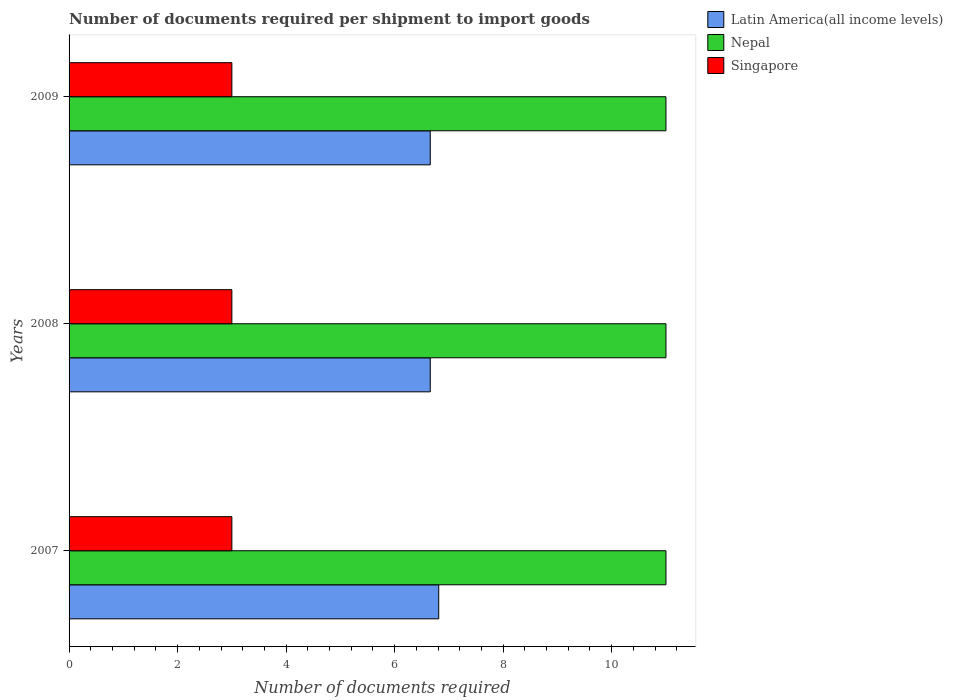How many different coloured bars are there?
Your response must be concise. 3. How many groups of bars are there?
Make the answer very short. 3. How many bars are there on the 1st tick from the top?
Keep it short and to the point. 3. How many bars are there on the 3rd tick from the bottom?
Offer a very short reply. 3. What is the label of the 2nd group of bars from the top?
Provide a short and direct response. 2008. In how many cases, is the number of bars for a given year not equal to the number of legend labels?
Offer a terse response. 0. What is the number of documents required per shipment to import goods in Nepal in 2009?
Provide a succinct answer. 11. Across all years, what is the maximum number of documents required per shipment to import goods in Nepal?
Provide a succinct answer. 11. Across all years, what is the minimum number of documents required per shipment to import goods in Singapore?
Offer a very short reply. 3. What is the total number of documents required per shipment to import goods in Latin America(all income levels) in the graph?
Give a very brief answer. 20.12. What is the difference between the number of documents required per shipment to import goods in Latin America(all income levels) in 2007 and that in 2008?
Your answer should be compact. 0.16. What is the difference between the number of documents required per shipment to import goods in Latin America(all income levels) in 2009 and the number of documents required per shipment to import goods in Singapore in 2008?
Make the answer very short. 3.66. What is the average number of documents required per shipment to import goods in Latin America(all income levels) per year?
Provide a succinct answer. 6.71. In the year 2008, what is the difference between the number of documents required per shipment to import goods in Latin America(all income levels) and number of documents required per shipment to import goods in Singapore?
Your response must be concise. 3.66. Is the number of documents required per shipment to import goods in Latin America(all income levels) in 2008 less than that in 2009?
Make the answer very short. No. What is the difference between the highest and the second highest number of documents required per shipment to import goods in Nepal?
Offer a very short reply. 0. In how many years, is the number of documents required per shipment to import goods in Singapore greater than the average number of documents required per shipment to import goods in Singapore taken over all years?
Your response must be concise. 0. Is the sum of the number of documents required per shipment to import goods in Nepal in 2007 and 2008 greater than the maximum number of documents required per shipment to import goods in Latin America(all income levels) across all years?
Give a very brief answer. Yes. What does the 3rd bar from the top in 2007 represents?
Provide a short and direct response. Latin America(all income levels). What does the 1st bar from the bottom in 2009 represents?
Ensure brevity in your answer.  Latin America(all income levels). Are the values on the major ticks of X-axis written in scientific E-notation?
Make the answer very short. No. Does the graph contain grids?
Keep it short and to the point. No. Where does the legend appear in the graph?
Provide a short and direct response. Top right. What is the title of the graph?
Provide a short and direct response. Number of documents required per shipment to import goods. What is the label or title of the X-axis?
Provide a short and direct response. Number of documents required. What is the label or title of the Y-axis?
Give a very brief answer. Years. What is the Number of documents required of Latin America(all income levels) in 2007?
Offer a very short reply. 6.81. What is the Number of documents required of Latin America(all income levels) in 2008?
Your answer should be compact. 6.66. What is the Number of documents required of Singapore in 2008?
Ensure brevity in your answer.  3. What is the Number of documents required in Latin America(all income levels) in 2009?
Provide a succinct answer. 6.66. What is the Number of documents required in Nepal in 2009?
Provide a short and direct response. 11. Across all years, what is the maximum Number of documents required in Latin America(all income levels)?
Give a very brief answer. 6.81. Across all years, what is the maximum Number of documents required of Singapore?
Provide a succinct answer. 3. Across all years, what is the minimum Number of documents required in Latin America(all income levels)?
Your answer should be very brief. 6.66. What is the total Number of documents required of Latin America(all income levels) in the graph?
Offer a very short reply. 20.12. What is the total Number of documents required of Singapore in the graph?
Give a very brief answer. 9. What is the difference between the Number of documents required in Latin America(all income levels) in 2007 and that in 2008?
Your answer should be very brief. 0.16. What is the difference between the Number of documents required of Latin America(all income levels) in 2007 and that in 2009?
Give a very brief answer. 0.16. What is the difference between the Number of documents required of Nepal in 2008 and that in 2009?
Your response must be concise. 0. What is the difference between the Number of documents required of Singapore in 2008 and that in 2009?
Keep it short and to the point. 0. What is the difference between the Number of documents required of Latin America(all income levels) in 2007 and the Number of documents required of Nepal in 2008?
Give a very brief answer. -4.19. What is the difference between the Number of documents required of Latin America(all income levels) in 2007 and the Number of documents required of Singapore in 2008?
Ensure brevity in your answer.  3.81. What is the difference between the Number of documents required in Nepal in 2007 and the Number of documents required in Singapore in 2008?
Provide a short and direct response. 8. What is the difference between the Number of documents required of Latin America(all income levels) in 2007 and the Number of documents required of Nepal in 2009?
Make the answer very short. -4.19. What is the difference between the Number of documents required of Latin America(all income levels) in 2007 and the Number of documents required of Singapore in 2009?
Keep it short and to the point. 3.81. What is the difference between the Number of documents required of Nepal in 2007 and the Number of documents required of Singapore in 2009?
Offer a very short reply. 8. What is the difference between the Number of documents required in Latin America(all income levels) in 2008 and the Number of documents required in Nepal in 2009?
Make the answer very short. -4.34. What is the difference between the Number of documents required in Latin America(all income levels) in 2008 and the Number of documents required in Singapore in 2009?
Provide a short and direct response. 3.66. What is the difference between the Number of documents required in Nepal in 2008 and the Number of documents required in Singapore in 2009?
Your response must be concise. 8. What is the average Number of documents required in Latin America(all income levels) per year?
Your answer should be compact. 6.71. What is the average Number of documents required of Singapore per year?
Provide a short and direct response. 3. In the year 2007, what is the difference between the Number of documents required in Latin America(all income levels) and Number of documents required in Nepal?
Provide a succinct answer. -4.19. In the year 2007, what is the difference between the Number of documents required of Latin America(all income levels) and Number of documents required of Singapore?
Give a very brief answer. 3.81. In the year 2008, what is the difference between the Number of documents required in Latin America(all income levels) and Number of documents required in Nepal?
Your response must be concise. -4.34. In the year 2008, what is the difference between the Number of documents required in Latin America(all income levels) and Number of documents required in Singapore?
Make the answer very short. 3.66. In the year 2009, what is the difference between the Number of documents required of Latin America(all income levels) and Number of documents required of Nepal?
Offer a very short reply. -4.34. In the year 2009, what is the difference between the Number of documents required in Latin America(all income levels) and Number of documents required in Singapore?
Your answer should be very brief. 3.66. In the year 2009, what is the difference between the Number of documents required in Nepal and Number of documents required in Singapore?
Keep it short and to the point. 8. What is the ratio of the Number of documents required in Latin America(all income levels) in 2007 to that in 2008?
Keep it short and to the point. 1.02. What is the ratio of the Number of documents required in Singapore in 2007 to that in 2008?
Your answer should be compact. 1. What is the ratio of the Number of documents required in Latin America(all income levels) in 2007 to that in 2009?
Offer a very short reply. 1.02. What is the ratio of the Number of documents required in Nepal in 2007 to that in 2009?
Your answer should be compact. 1. What is the ratio of the Number of documents required in Latin America(all income levels) in 2008 to that in 2009?
Give a very brief answer. 1. What is the ratio of the Number of documents required in Nepal in 2008 to that in 2009?
Provide a succinct answer. 1. What is the ratio of the Number of documents required in Singapore in 2008 to that in 2009?
Make the answer very short. 1. What is the difference between the highest and the second highest Number of documents required of Latin America(all income levels)?
Offer a very short reply. 0.16. What is the difference between the highest and the second highest Number of documents required in Singapore?
Ensure brevity in your answer.  0. What is the difference between the highest and the lowest Number of documents required of Latin America(all income levels)?
Provide a short and direct response. 0.16. What is the difference between the highest and the lowest Number of documents required of Nepal?
Provide a short and direct response. 0. 